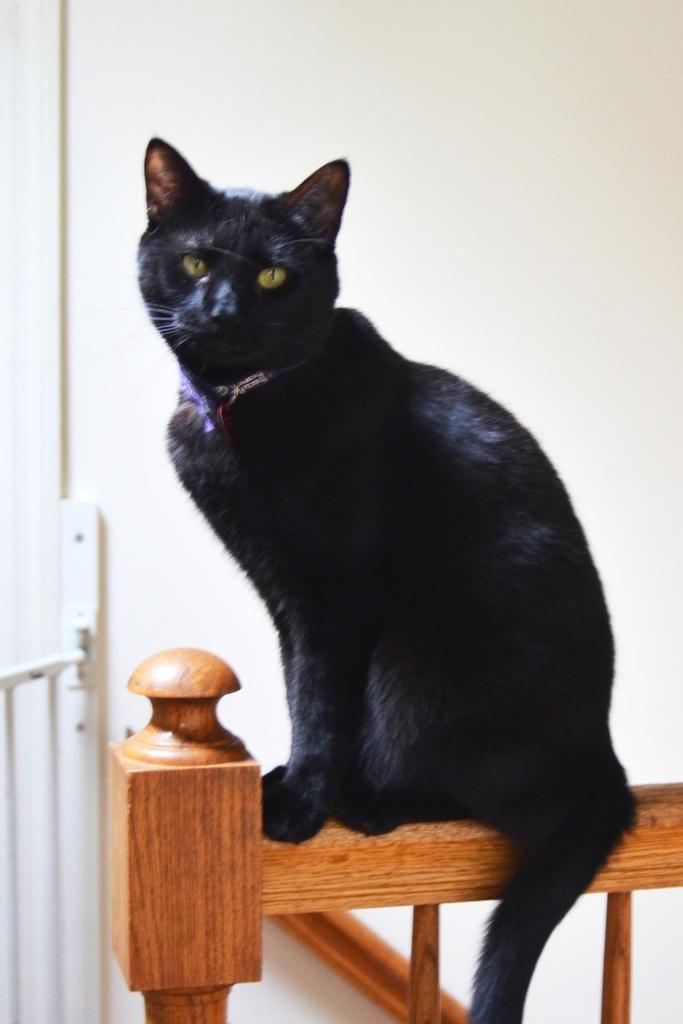Please provide a concise description of this image. In the picture I can see a black cat sitting on a wooden fence and there are some other objects in the left corner. 